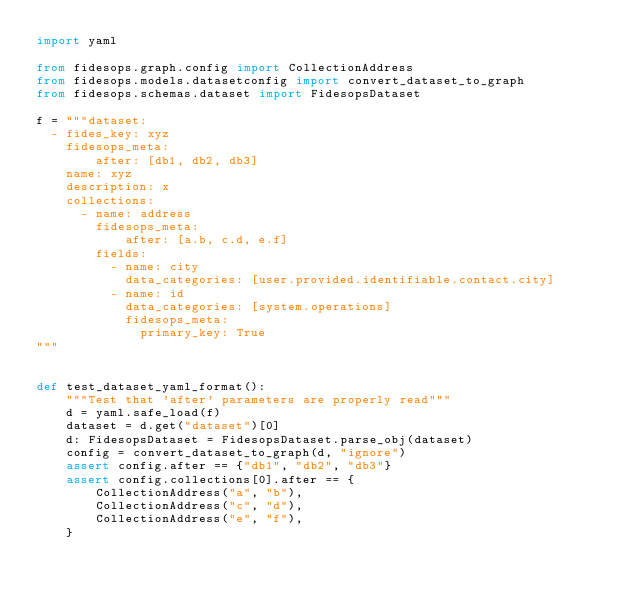<code> <loc_0><loc_0><loc_500><loc_500><_Python_>import yaml

from fidesops.graph.config import CollectionAddress
from fidesops.models.datasetconfig import convert_dataset_to_graph
from fidesops.schemas.dataset import FidesopsDataset

f = """dataset:
  - fides_key: xyz
    fidesops_meta:
        after: [db1, db2, db3]        
    name: xyz
    description: x
    collections:
      - name: address
        fidesops_meta:
            after: [a.b, c.d, e.f]
        fields:
          - name: city
            data_categories: [user.provided.identifiable.contact.city] 
          - name: id
            data_categories: [system.operations]
            fidesops_meta:
              primary_key: True  
"""


def test_dataset_yaml_format():
    """Test that 'after' parameters are properly read"""
    d = yaml.safe_load(f)
    dataset = d.get("dataset")[0]
    d: FidesopsDataset = FidesopsDataset.parse_obj(dataset)
    config = convert_dataset_to_graph(d, "ignore")
    assert config.after == {"db1", "db2", "db3"}
    assert config.collections[0].after == {
        CollectionAddress("a", "b"),
        CollectionAddress("c", "d"),
        CollectionAddress("e", "f"),
    }
</code> 